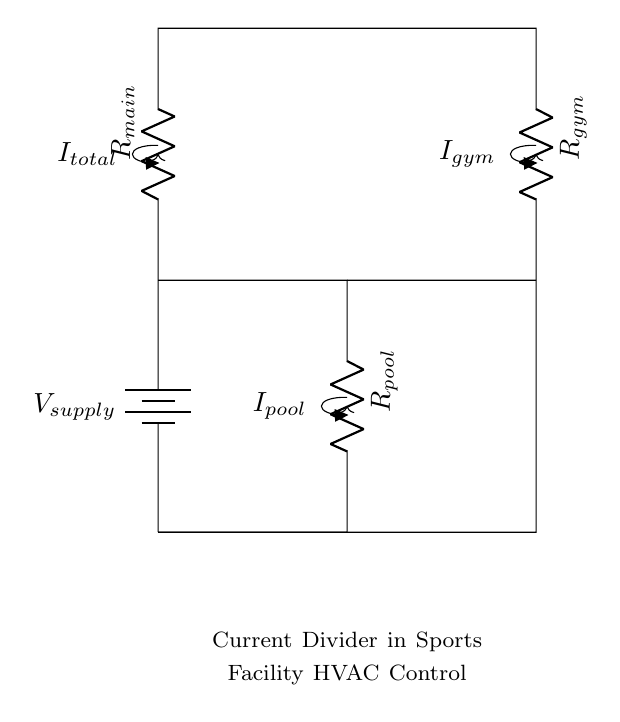What is the total current entering the circuit? The total current entering the circuit is represented by the label I_total, which is indicated at the top of the diagram.
Answer: I_total What components are used in the circuit? The circuit contains a battery, a main resistor labeled R_main, and two additional resistors labeled R_pool and R_gym.
Answer: Battery, R_main, R_pool, R_gym What is the current flowing through the gym resistor? The current flowing through the gym resistor is indicated as I_gym, shown on the right side of the circuit.
Answer: I_gym How are the pool and gym resistors connected? The pool and gym resistors are connected in parallel, as they share both the same voltage across their terminals and the same connection to the main circuit.
Answer: Parallel What can you conclude about the total voltage supplied? The total voltage supplied is the same across all components in this configuration because they are in parallel, with the main battery providing the voltage V_supply.
Answer: V_supply Which resistor has the highest current flowing through it? The resistor with the highest current can be inferred as having the lowest resistance, but without specific values, we cannot definitively state which resistor, R_pool or R_gym, carries more current. However, assuming equal resistance, both would share the current equally.
Answer: Depends on resistance values 